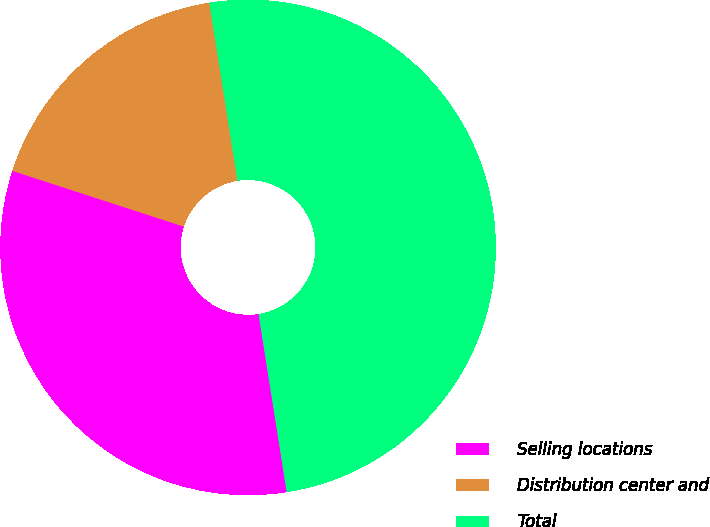Convert chart. <chart><loc_0><loc_0><loc_500><loc_500><pie_chart><fcel>Selling locations<fcel>Distribution center and<fcel>Total<nl><fcel>32.5%<fcel>17.5%<fcel>50.0%<nl></chart> 